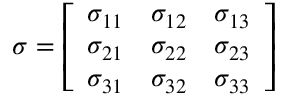Convert formula to latex. <formula><loc_0><loc_0><loc_500><loc_500>{ \sigma } = \left [ { \begin{array} { l l l } { \sigma _ { 1 1 } } & { \sigma _ { 1 2 } } & { \sigma _ { 1 3 } } \\ { \sigma _ { 2 1 } } & { \sigma _ { 2 2 } } & { \sigma _ { 2 3 } } \\ { \sigma _ { 3 1 } } & { \sigma _ { 3 2 } } & { \sigma _ { 3 3 } } \end{array} } \right ]</formula> 